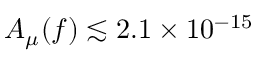Convert formula to latex. <formula><loc_0><loc_0><loc_500><loc_500>A _ { \mu } ( f ) \lesssim 2 . 1 \times 1 0 ^ { - 1 5 }</formula> 